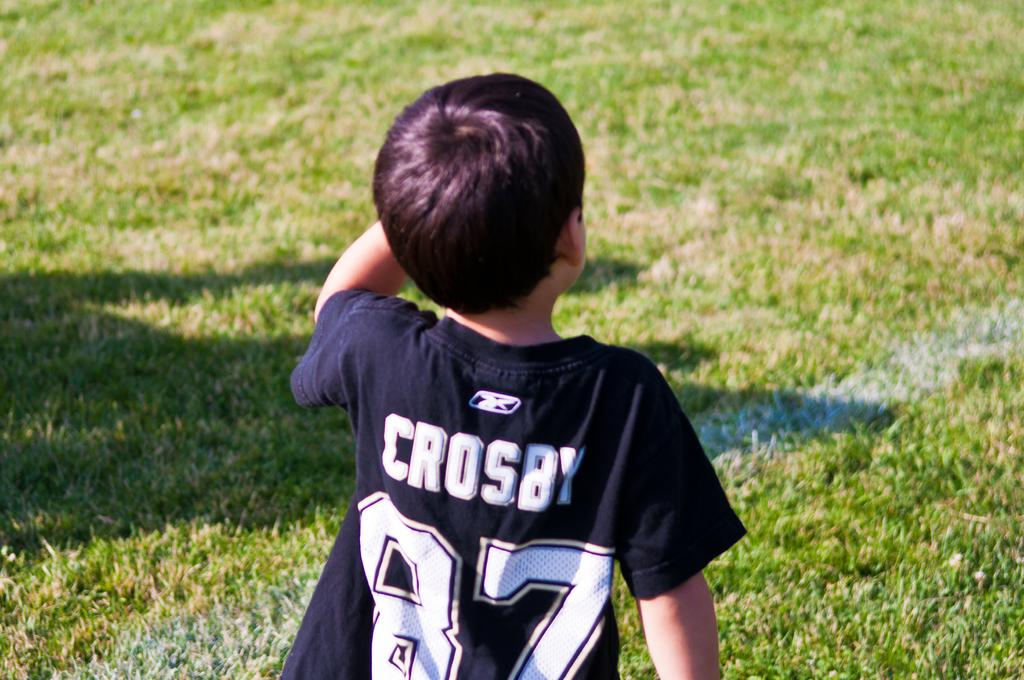<image>
Present a compact description of the photo's key features. A young boy in jersey with the name Crosby on the back. 